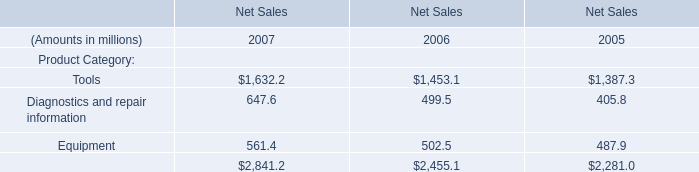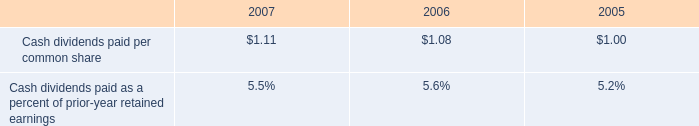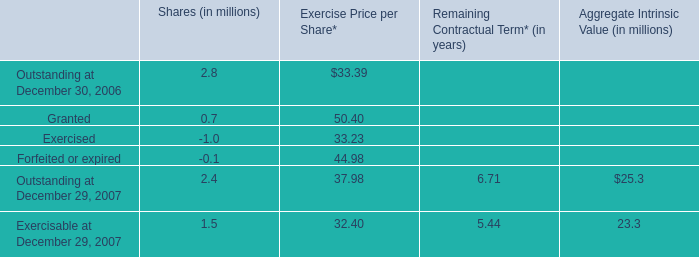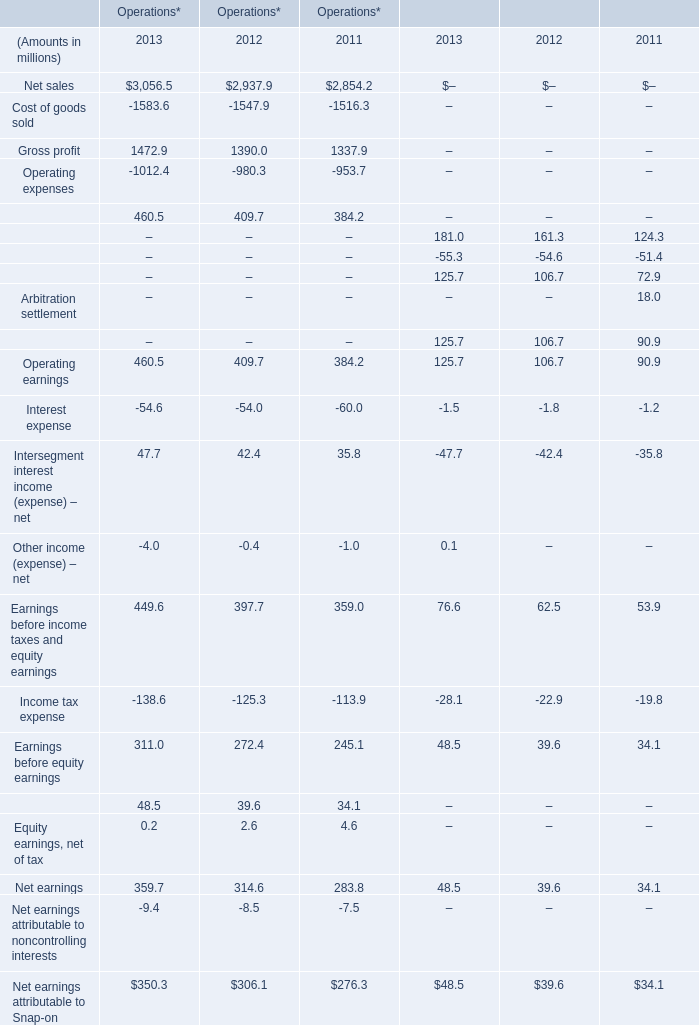What's the sum of Tools of Net Sales 2007, Cost of goods sold of Operations* 2012, and total of Net Sales 2007 ? 
Computations: ((1632.2 + 1547.9) + 2841.2)
Answer: 6021.3. 